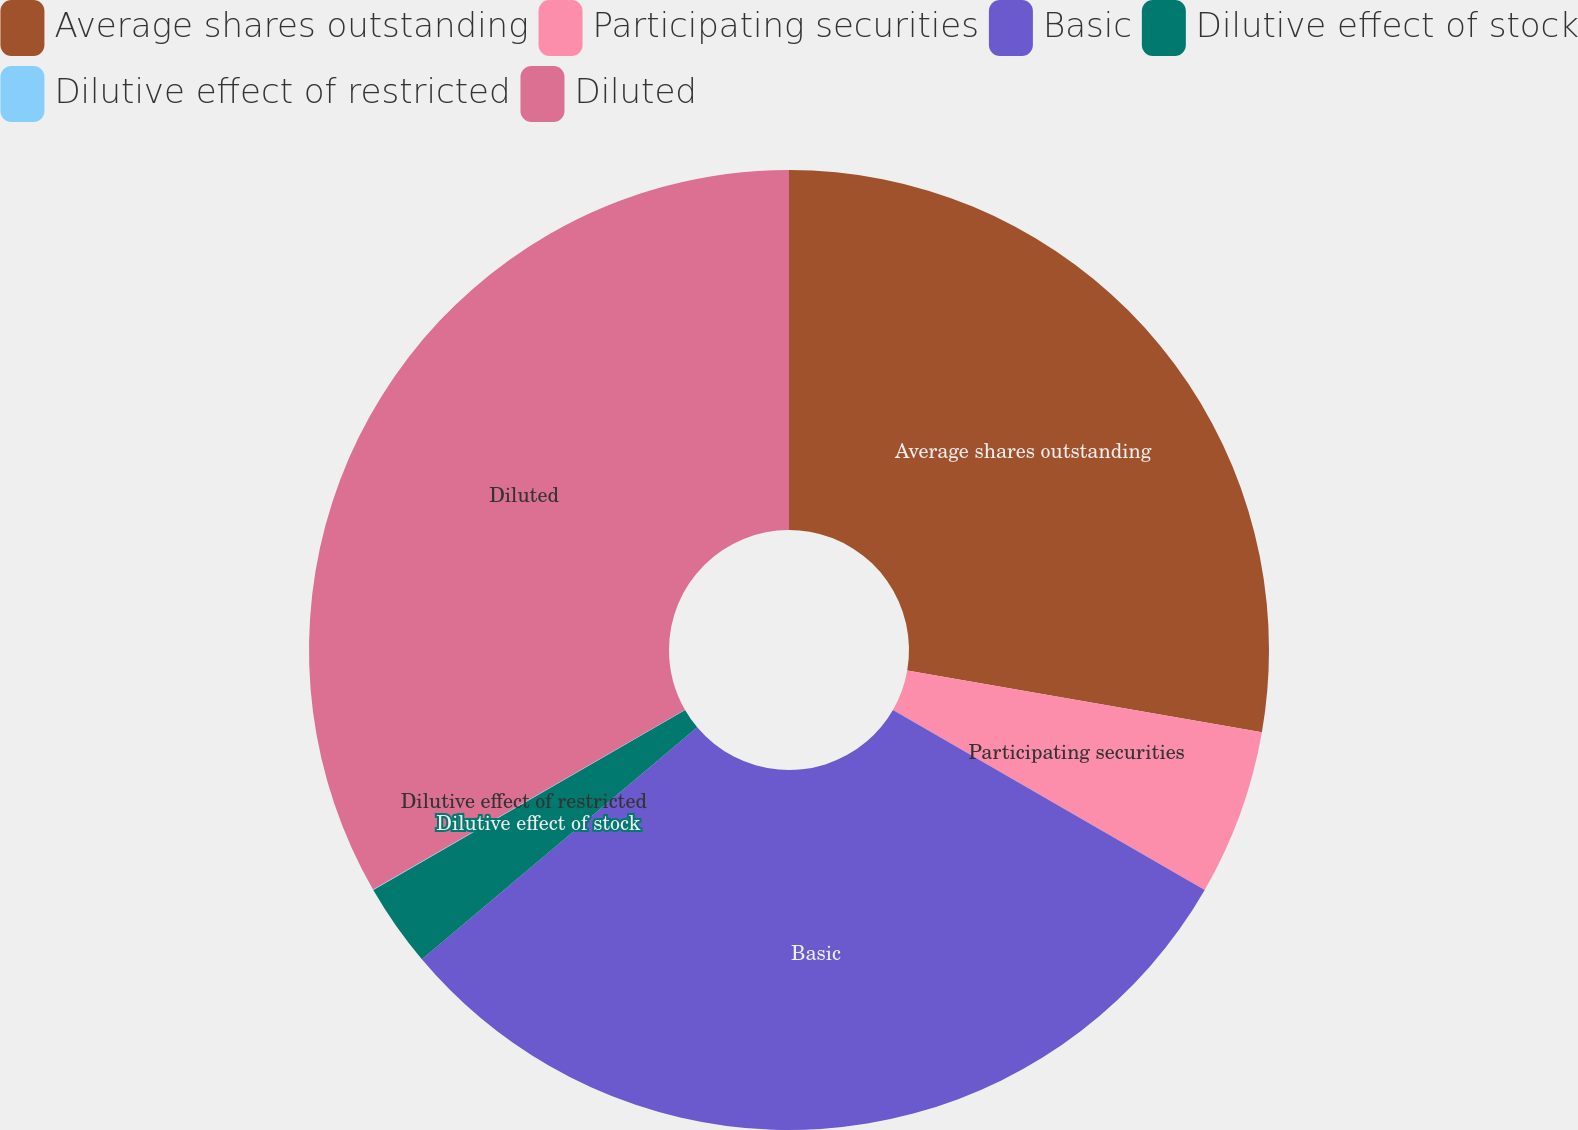Convert chart to OTSL. <chart><loc_0><loc_0><loc_500><loc_500><pie_chart><fcel>Average shares outstanding<fcel>Participating securities<fcel>Basic<fcel>Dilutive effect of stock<fcel>Dilutive effect of restricted<fcel>Diluted<nl><fcel>27.74%<fcel>5.59%<fcel>30.53%<fcel>2.81%<fcel>0.02%<fcel>33.31%<nl></chart> 